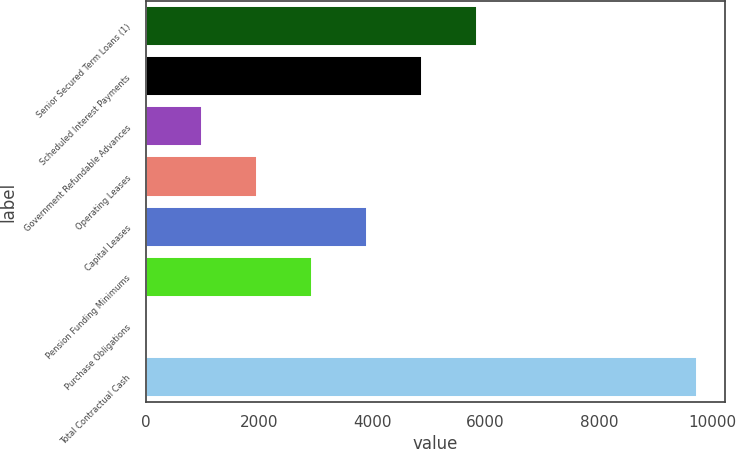<chart> <loc_0><loc_0><loc_500><loc_500><bar_chart><fcel>Senior Secured Term Loans (1)<fcel>Scheduled Interest Payments<fcel>Government Refundable Advances<fcel>Operating Leases<fcel>Capital Leases<fcel>Pension Funding Minimums<fcel>Purchase Obligations<fcel>Total Contractual Cash<nl><fcel>5845.74<fcel>4873.85<fcel>986.29<fcel>1958.18<fcel>3901.96<fcel>2930.07<fcel>14.4<fcel>9733.3<nl></chart> 